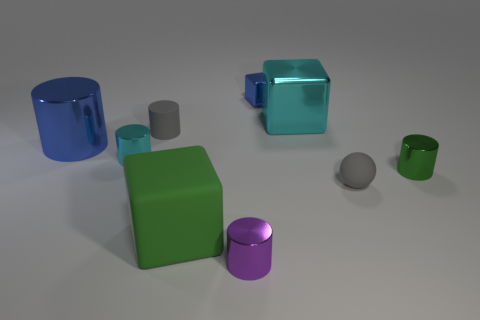What material is the cylinder that is the same color as the ball?
Keep it short and to the point. Rubber. Is there a green cylinder that has the same material as the small blue object?
Keep it short and to the point. Yes. What number of cyan shiny objects are the same shape as the tiny green thing?
Keep it short and to the point. 1. The metallic object behind the large cube that is behind the large metal object in front of the cyan metallic cube is what shape?
Offer a very short reply. Cube. There is a small object that is behind the big blue metal object and in front of the small blue metal thing; what material is it?
Ensure brevity in your answer.  Rubber. There is a gray object left of the blue shiny block; is its size the same as the cyan metal cylinder?
Provide a short and direct response. Yes. Is the number of things on the left side of the tiny green shiny thing greater than the number of large objects that are in front of the small ball?
Provide a short and direct response. Yes. What is the color of the large metal thing to the left of the cyan thing that is in front of the big cube that is behind the gray cylinder?
Offer a very short reply. Blue. There is a large metal object that is on the left side of the tiny blue metal object; is it the same color as the tiny block?
Provide a short and direct response. Yes. How many other things are there of the same color as the matte cylinder?
Offer a very short reply. 1. 